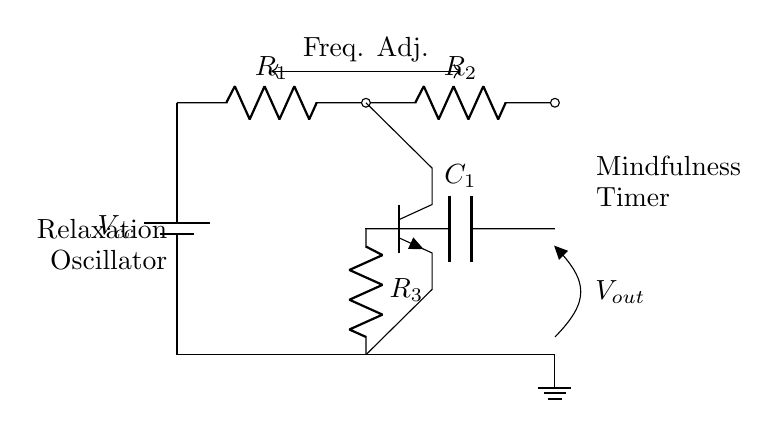What is the type of oscillator represented? The circuit diagram represents a relaxation oscillator, which is indicated by the label "Relaxation Oscillator" on the left side of the diagram.
Answer: Relaxation oscillator What are the key components used in this circuit? The circuit includes a battery, resistors, a capacitor, and a transistor. Each component has been labeled in the circuit diagram, confirming their types.
Answer: Battery, resistors, capacitor, transistor How many resistors are in the circuit? By counting the labeled resistors in the circuit, there are three resistors indicated: R1, R2, and R3.
Answer: Three What is the purpose of the output labeled as Vout? The output Vout serves as the signal for the mindfulness timer, as noted in the diagram where it's specifically labeled for this function.
Answer: Mindfulness timer signal How does frequency adjustment affect the oscillator? The frequency adjustment allows the user to modify the oscillation rate by changing the resistance in the circuit, which in turn alters the charging and discharging time of the capacitor. This is noted between the indicated points in the diagram.
Answer: Alters the oscillation rate What role does the transistor play in this circuit? The transistor acts as a switch or amplifier in the relaxation oscillator, controlling the flow of current based on the charge in the capacitor, which is a key function in oscillation. This reasoning can be derived from its connections and common function in similar circuits.
Answer: Switch or amplifier What is the function of the capacitor labeled C1? The capacitor C1 stores and releases electrical energy, essential for generating the timing intervals in the oscillator circuit. This function underlies the operation of the relaxation oscillator, as indicated by its placement and connections.
Answer: Timing intervals generator 